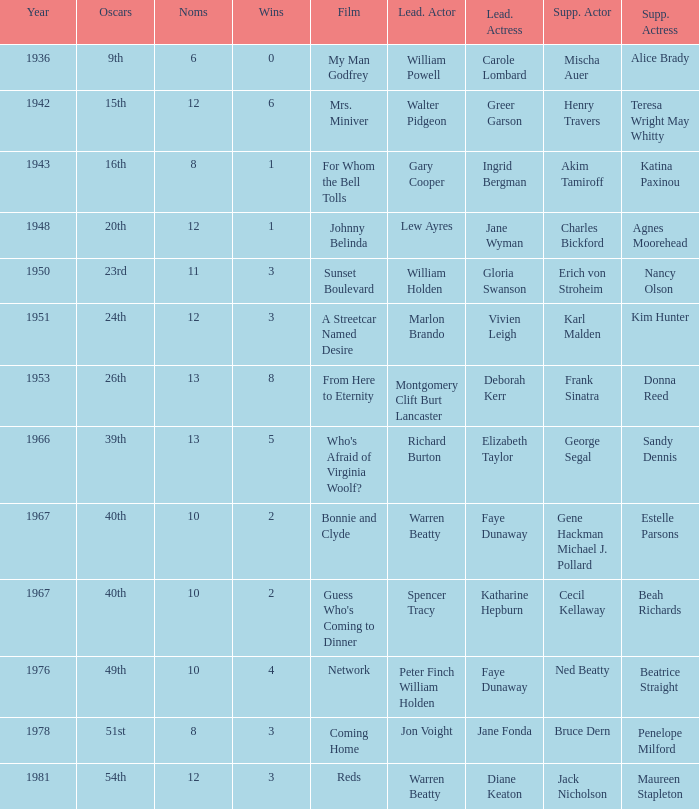Who was the supporting actress in a film with Diane Keaton as the leading actress? Maureen Stapleton. 